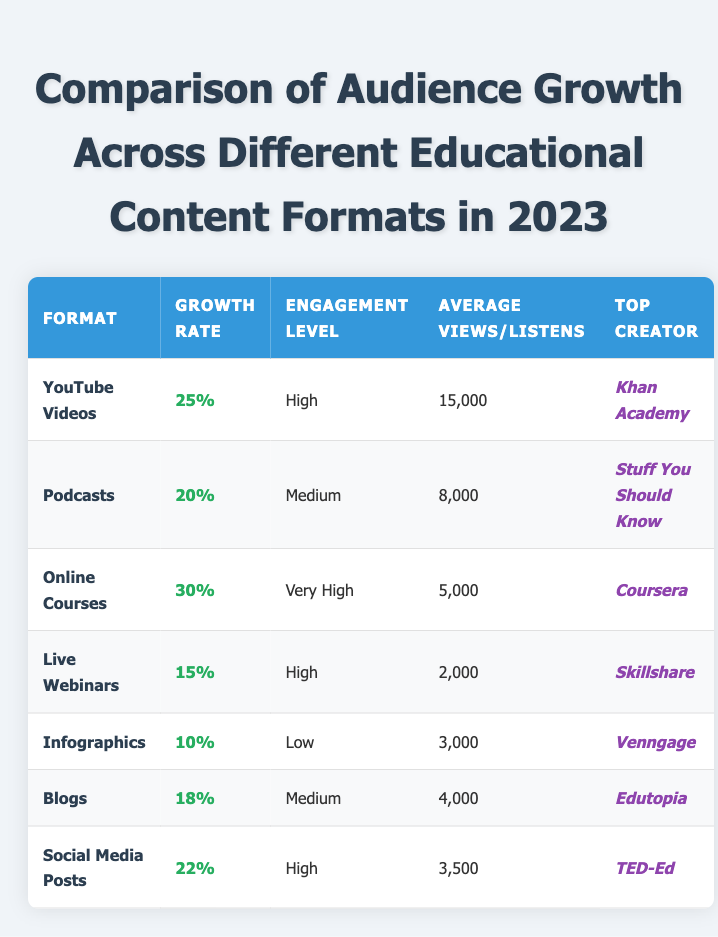What is the top creator for Online Courses? The table shows that the top creator for Online Courses is **Coursera**.
Answer: Coursera Which format has the highest audience growth rate? The table indicates that Online Courses have the highest growth rate at 30%.
Answer: 30% How many average views do YouTube Videos receive? According to the table, YouTube Videos receive an average of 15,000 views.
Answer: 15,000 Is the engagement level for Infographics high? The table reveals that the engagement level for Infographics is listed as Low, not high.
Answer: No What is the difference in growth rate between Live Webinars and Social Media Posts? Live Webinars have a growth rate of 15% and Social Media Posts have 22%. The difference is 22% - 15% = 7%.
Answer: 7% What is the average engagement level of the formats listed? There are seven formats with the following engagement levels: High, Medium, Very High, High, Low, Medium, High. When averaging the numerical values assigned to these categories (2 for Low, 3 for Medium, 4 for High, 5 for Very High), we count the occurrences: High (3), Medium (2), Very High (1), Low (1). The average becomes (3*4 + 2*3 + 1*5 + 1*2) / 7 = (12 + 6 + 5 + 2) / 7 = 25 / 7 ≈ 3.57, which corresponds to Medium between Medium and High.
Answer: Medium-High Which format has the lowest average views or listens? The table shows that Live Webinars have the lowest average of 2,000 attendees.
Answer: 2,000 What percentage of growth is observed in Podcasts compared to Infographics? Podcasts have a growth rate of 20% while Infographics have 10%. The difference is 20% - 10% = 10%, indicating that Podcasts have 10% higher growth.
Answer: 10% higher How do the average enrollments in Online Courses compare to average listens in Podcasts? Online Courses have 5,000 average enrollments, while Podcasts have 8,000 average listens. Therefore, Podcasts have 3,000 more average listens than Online Courses.
Answer: 3,000 more 